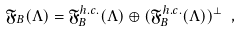<formula> <loc_0><loc_0><loc_500><loc_500>\mathfrak { F } _ { B } ( \Lambda ) = \mathfrak { F } _ { B } ^ { h . c . } ( \Lambda ) \oplus ( \mathfrak { F } _ { B } ^ { h . c . } ( \Lambda ) ) ^ { \bot } \ ,</formula> 